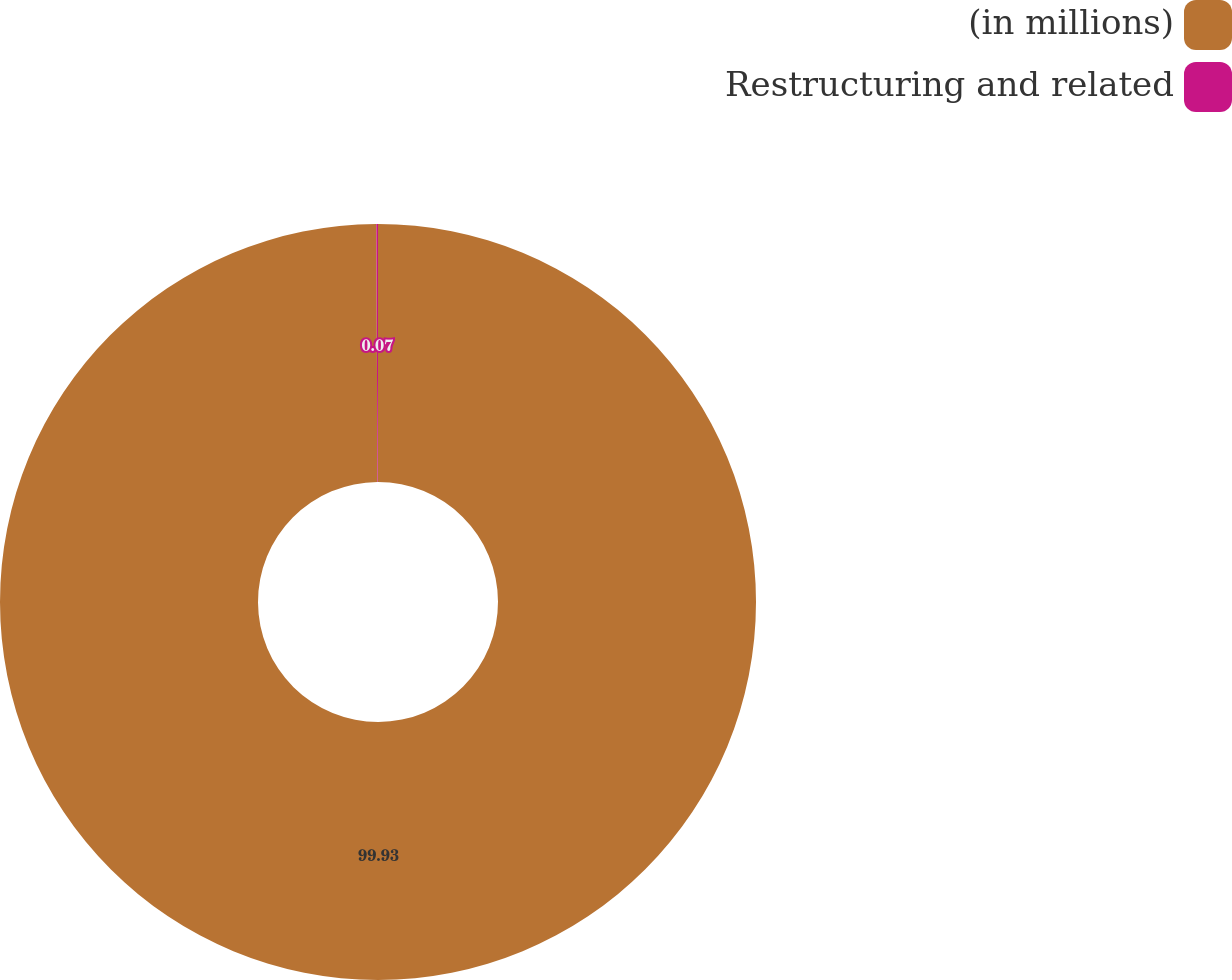<chart> <loc_0><loc_0><loc_500><loc_500><pie_chart><fcel>(in millions)<fcel>Restructuring and related<nl><fcel>99.93%<fcel>0.07%<nl></chart> 